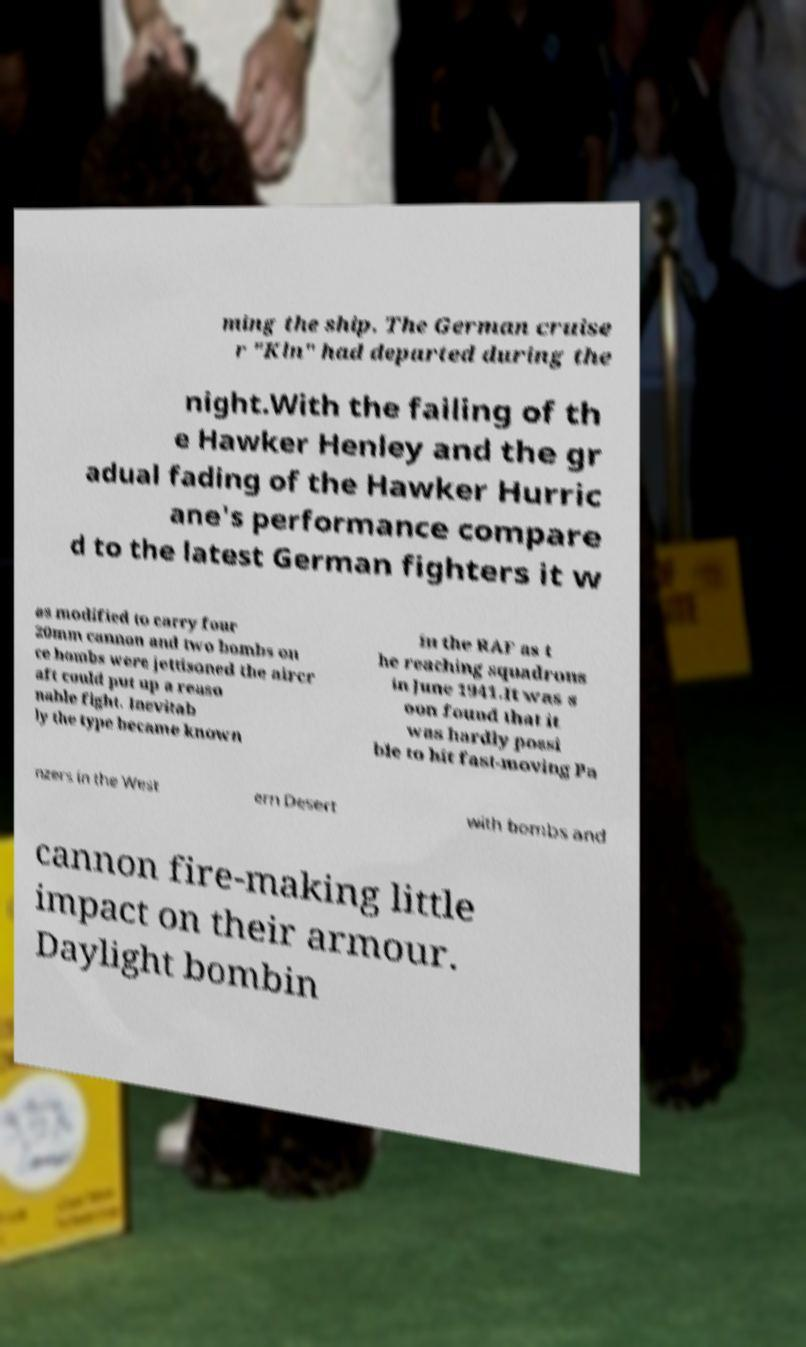For documentation purposes, I need the text within this image transcribed. Could you provide that? ming the ship. The German cruise r "Kln" had departed during the night.With the failing of th e Hawker Henley and the gr adual fading of the Hawker Hurric ane's performance compare d to the latest German fighters it w as modified to carry four 20mm cannon and two bombs on ce bombs were jettisoned the aircr aft could put up a reaso nable fight. Inevitab ly the type became known in the RAF as t he reaching squadrons in June 1941.It was s oon found that it was hardly possi ble to hit fast-moving Pa nzers in the West ern Desert with bombs and cannon fire-making little impact on their armour. Daylight bombin 